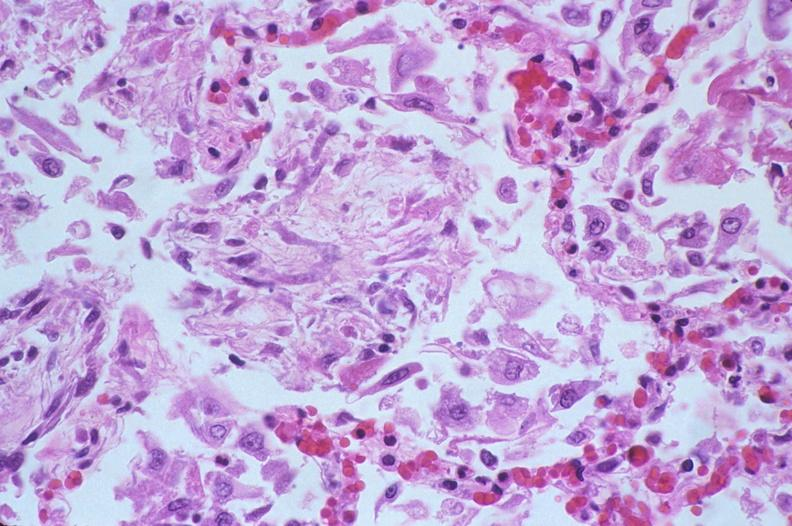what is present?
Answer the question using a single word or phrase. Respiratory 